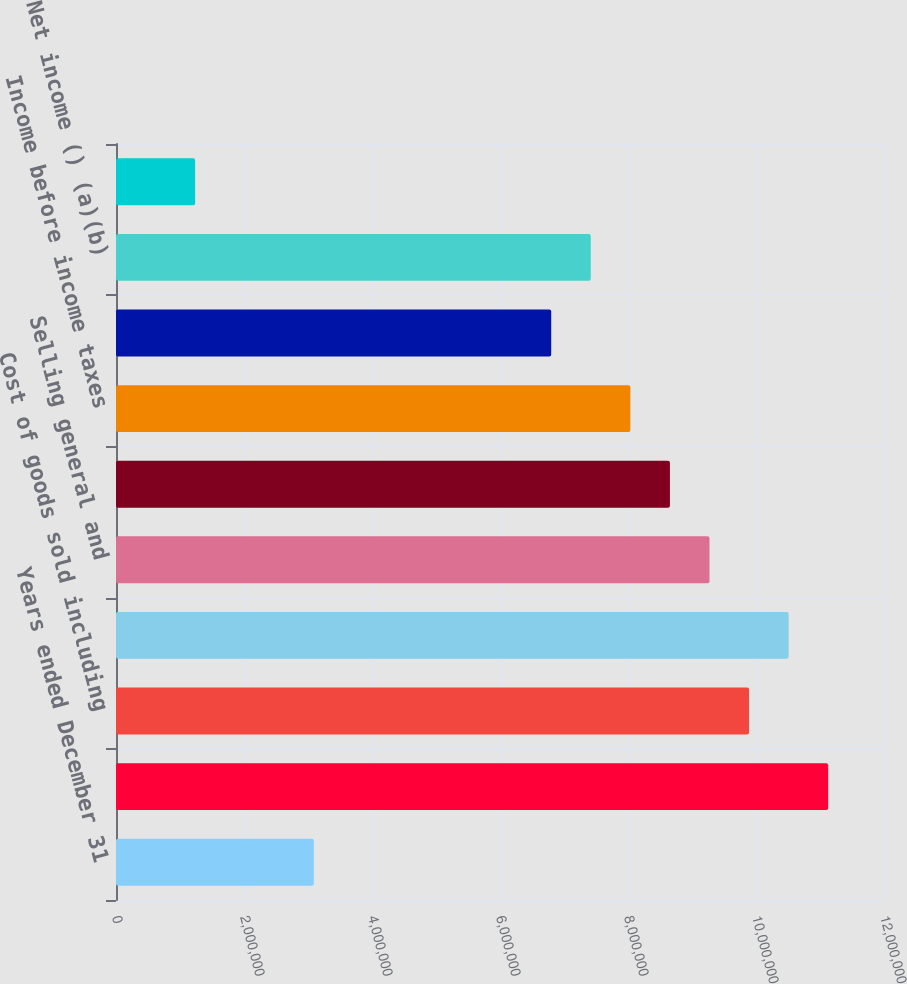Convert chart. <chart><loc_0><loc_0><loc_500><loc_500><bar_chart><fcel>Years ended December 31<fcel>Sales ()<fcel>Cost of goods sold including<fcel>Gross profit<fcel>Selling general and<fcel>Operating income<fcel>Income before income taxes<fcel>Provision for income taxes (a)<fcel>Net income () (a)(b)<fcel>Earnings per share - basic ()<nl><fcel>3.09109e+06<fcel>1.11279e+07<fcel>9.89149e+06<fcel>1.05097e+07<fcel>9.27327e+06<fcel>8.65506e+06<fcel>8.03684e+06<fcel>6.8004e+06<fcel>7.41862e+06<fcel>1.23644e+06<nl></chart> 